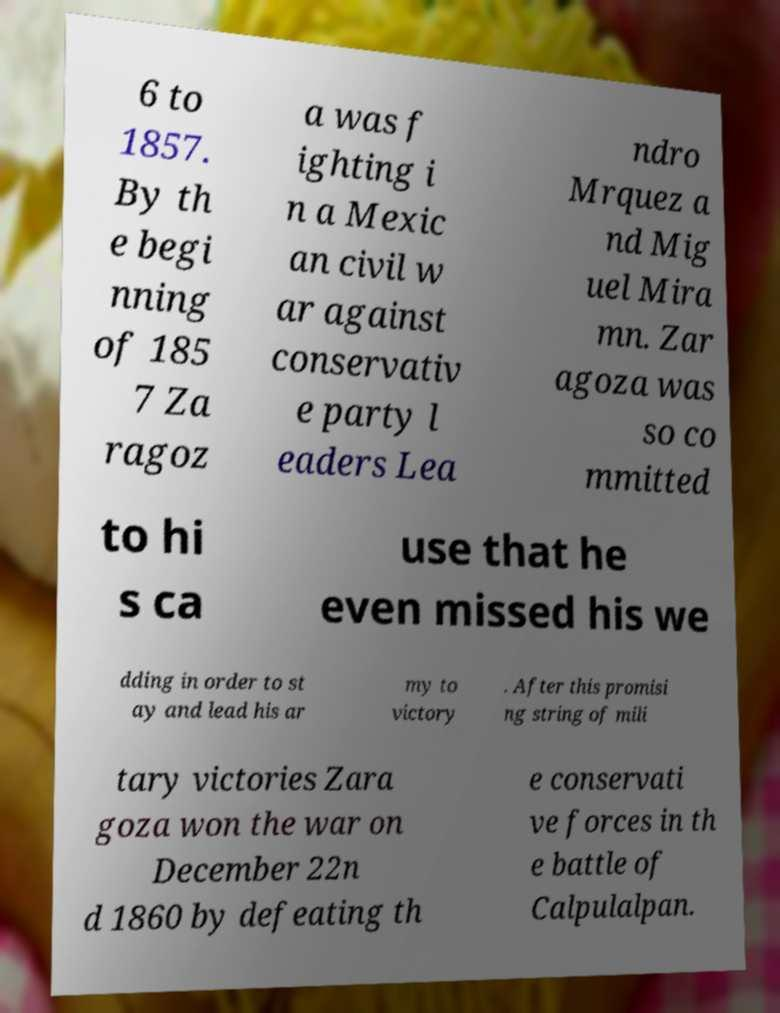Please identify and transcribe the text found in this image. 6 to 1857. By th e begi nning of 185 7 Za ragoz a was f ighting i n a Mexic an civil w ar against conservativ e party l eaders Lea ndro Mrquez a nd Mig uel Mira mn. Zar agoza was so co mmitted to hi s ca use that he even missed his we dding in order to st ay and lead his ar my to victory . After this promisi ng string of mili tary victories Zara goza won the war on December 22n d 1860 by defeating th e conservati ve forces in th e battle of Calpulalpan. 